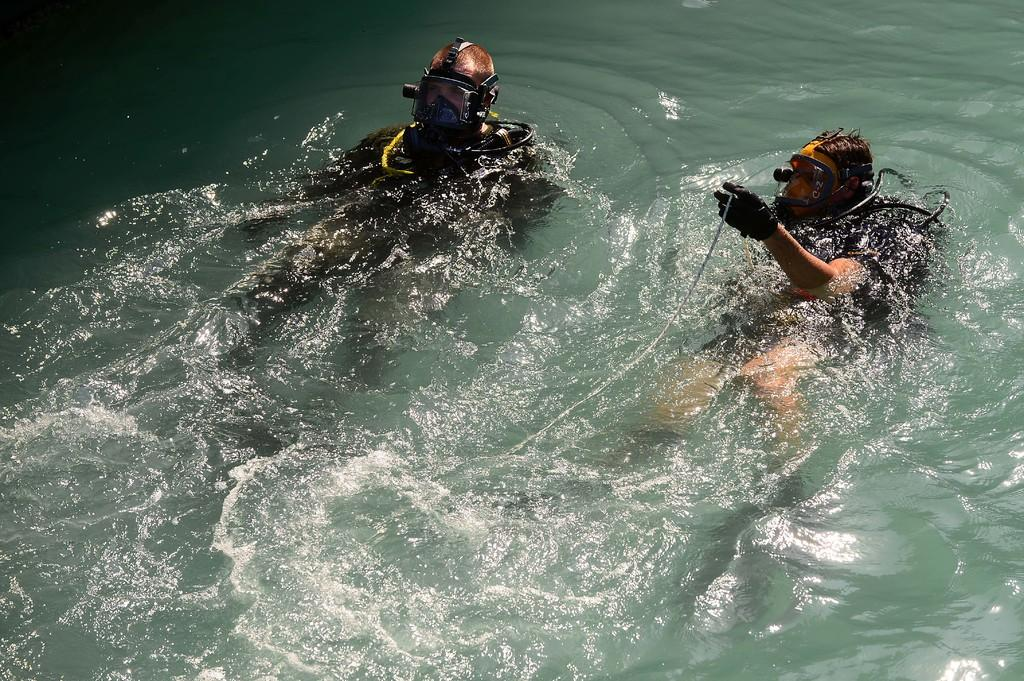What is visible in the image? Water is visible in the image. Are there any people in the image? Yes, there are two persons in the water. How does the dust affect the water in the image? There is no dust present in the image, so it cannot affect the water. 